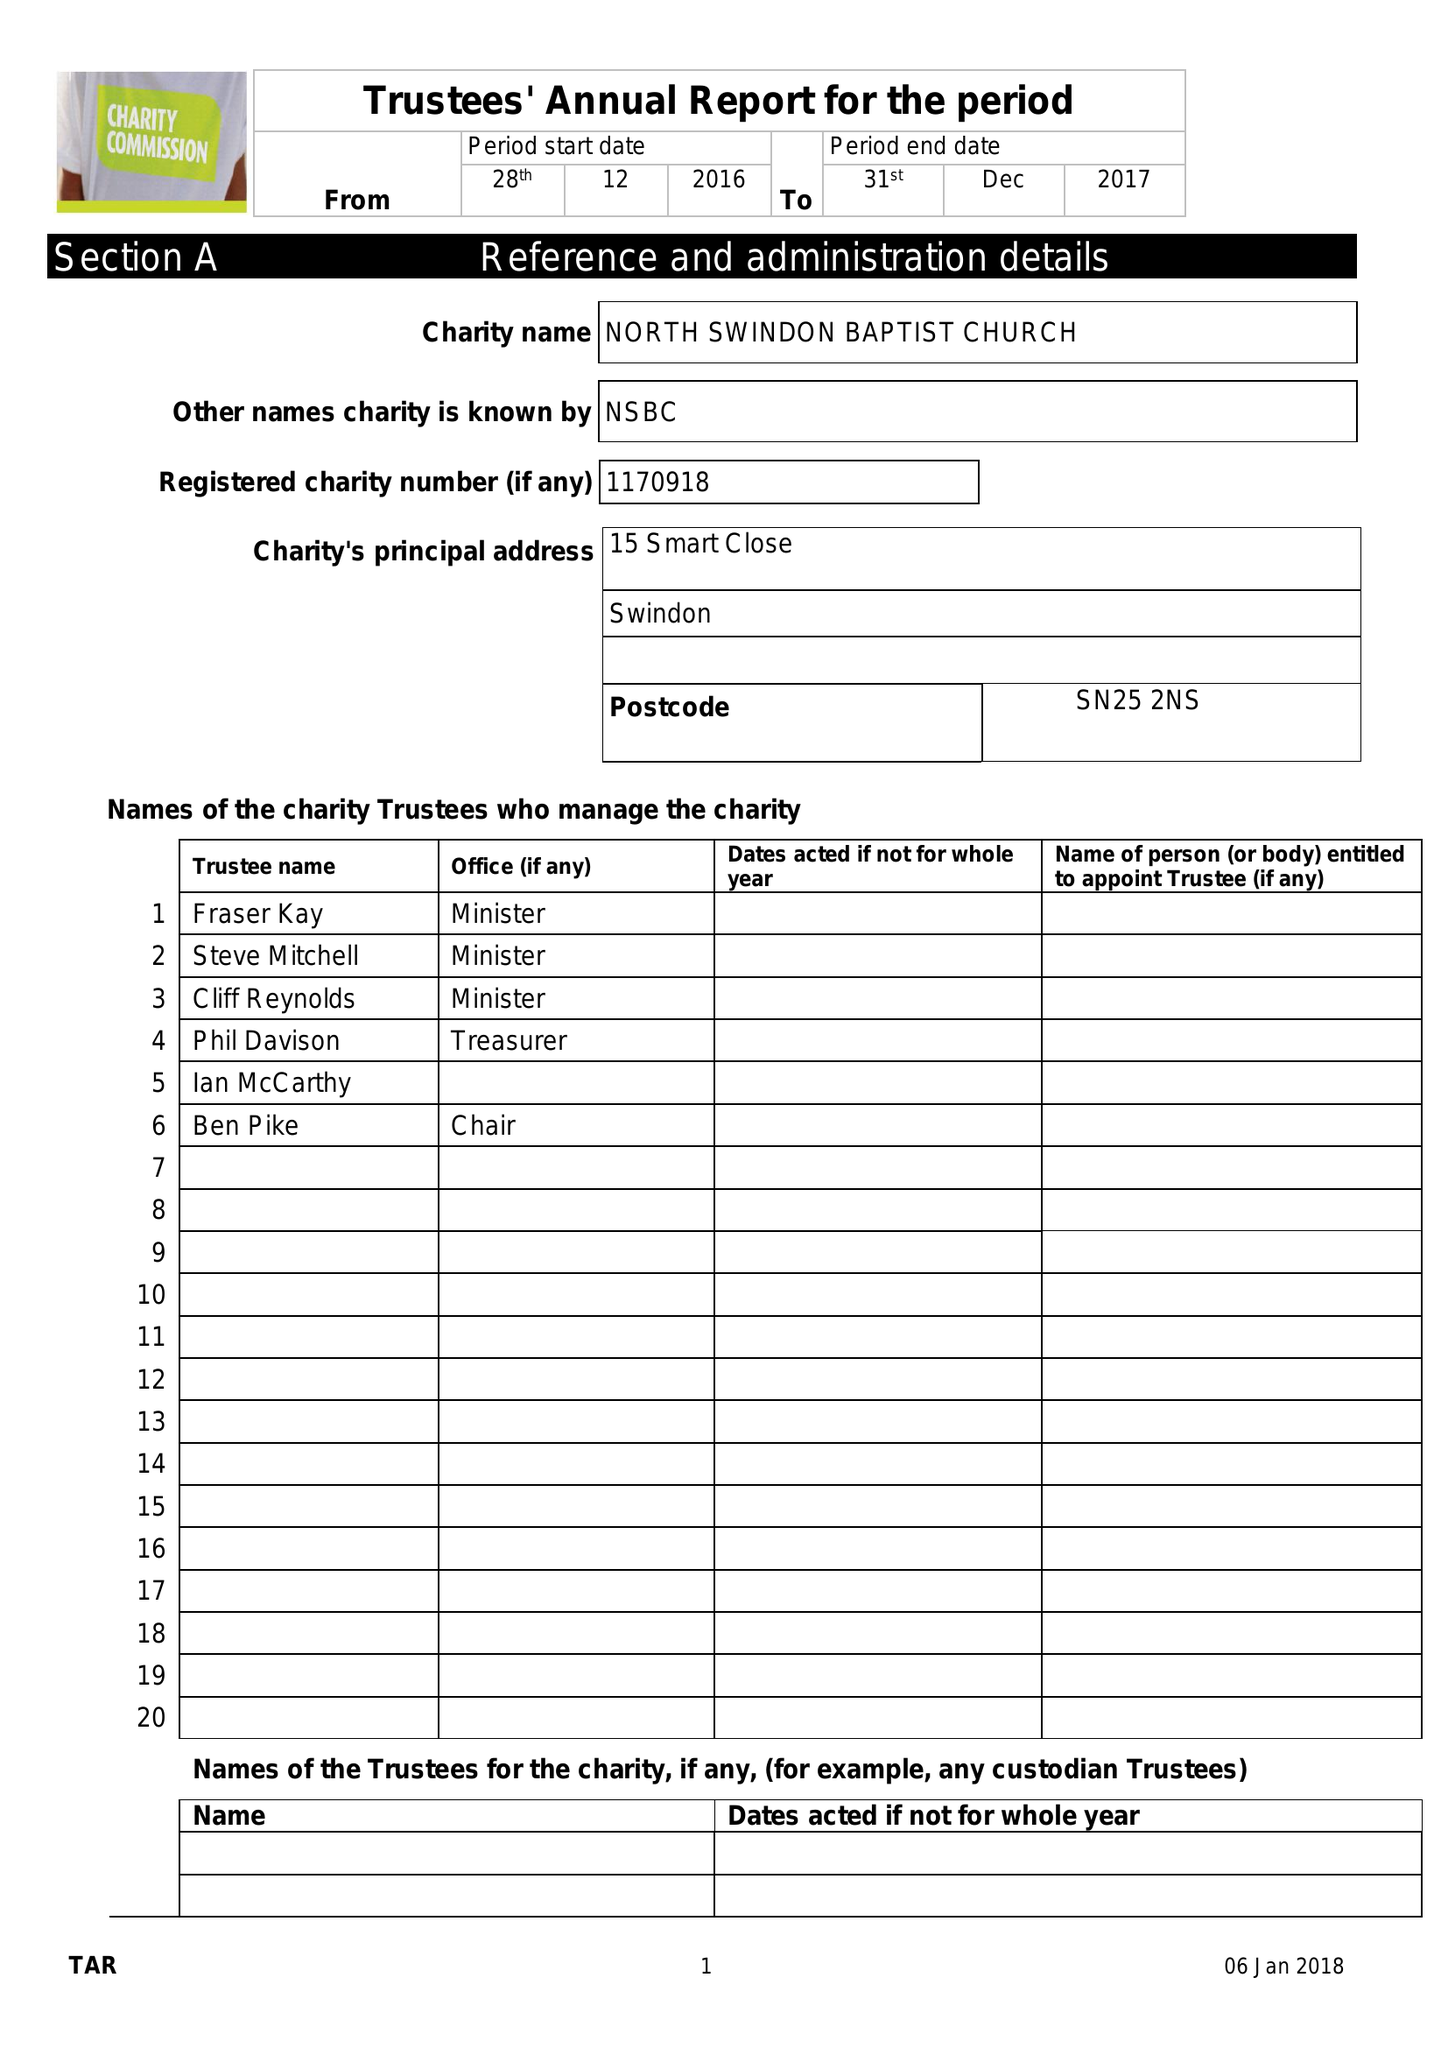What is the value for the spending_annually_in_british_pounds?
Answer the question using a single word or phrase. 144540.00 